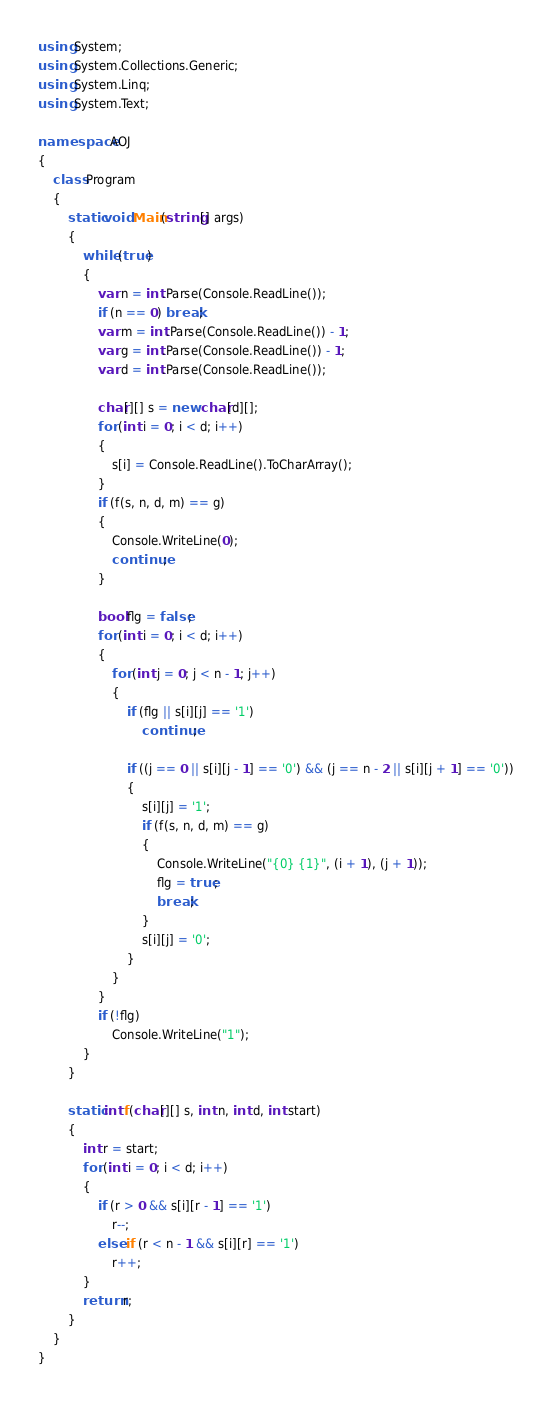<code> <loc_0><loc_0><loc_500><loc_500><_C#_>using System;
using System.Collections.Generic;
using System.Linq;
using System.Text;

namespace AOJ
{
	class Program
	{
		static void Main(string[] args)
		{
			while (true)
			{
				var n = int.Parse(Console.ReadLine());
				if (n == 0) break;
				var m = int.Parse(Console.ReadLine()) - 1;
				var g = int.Parse(Console.ReadLine()) - 1;
				var d = int.Parse(Console.ReadLine());

				char[][] s = new char[d][];
				for (int i = 0; i < d; i++)
				{
					s[i] = Console.ReadLine().ToCharArray();
				}
				if (f(s, n, d, m) == g)
				{
					Console.WriteLine(0);
					continue;
				}

				bool flg = false;
				for (int i = 0; i < d; i++)
				{
					for (int j = 0; j < n - 1; j++)
					{
						if (flg || s[i][j] == '1')
							continue;

						if ((j == 0 || s[i][j - 1] == '0') && (j == n - 2 || s[i][j + 1] == '0'))
						{
							s[i][j] = '1';
							if (f(s, n, d, m) == g)
							{
								Console.WriteLine("{0} {1}", (i + 1), (j + 1));
								flg = true;
								break;
							}
							s[i][j] = '0';
						}
					}
				}
				if (!flg)
					Console.WriteLine("1");
			}
		}

		static int f(char[][] s, int n, int d, int start)
		{
			int r = start;
			for (int i = 0; i < d; i++)
			{
				if (r > 0 && s[i][r - 1] == '1')
					r--;
				else if (r < n - 1 && s[i][r] == '1')
					r++;
			}
			return r;
		}
	}
}</code> 